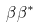<formula> <loc_0><loc_0><loc_500><loc_500>\beta \beta ^ { * }</formula> 